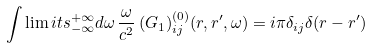<formula> <loc_0><loc_0><loc_500><loc_500>\int \lim i t s _ { - \infty } ^ { + \infty } d \omega \, \frac { \omega } { c ^ { 2 } } \, ( G _ { 1 } ) _ { i j } ^ { ( 0 ) } ( { r } , { r } ^ { \prime } , \omega ) = i \pi \delta _ { i j } \delta ( { r } - { r } ^ { \prime } )</formula> 